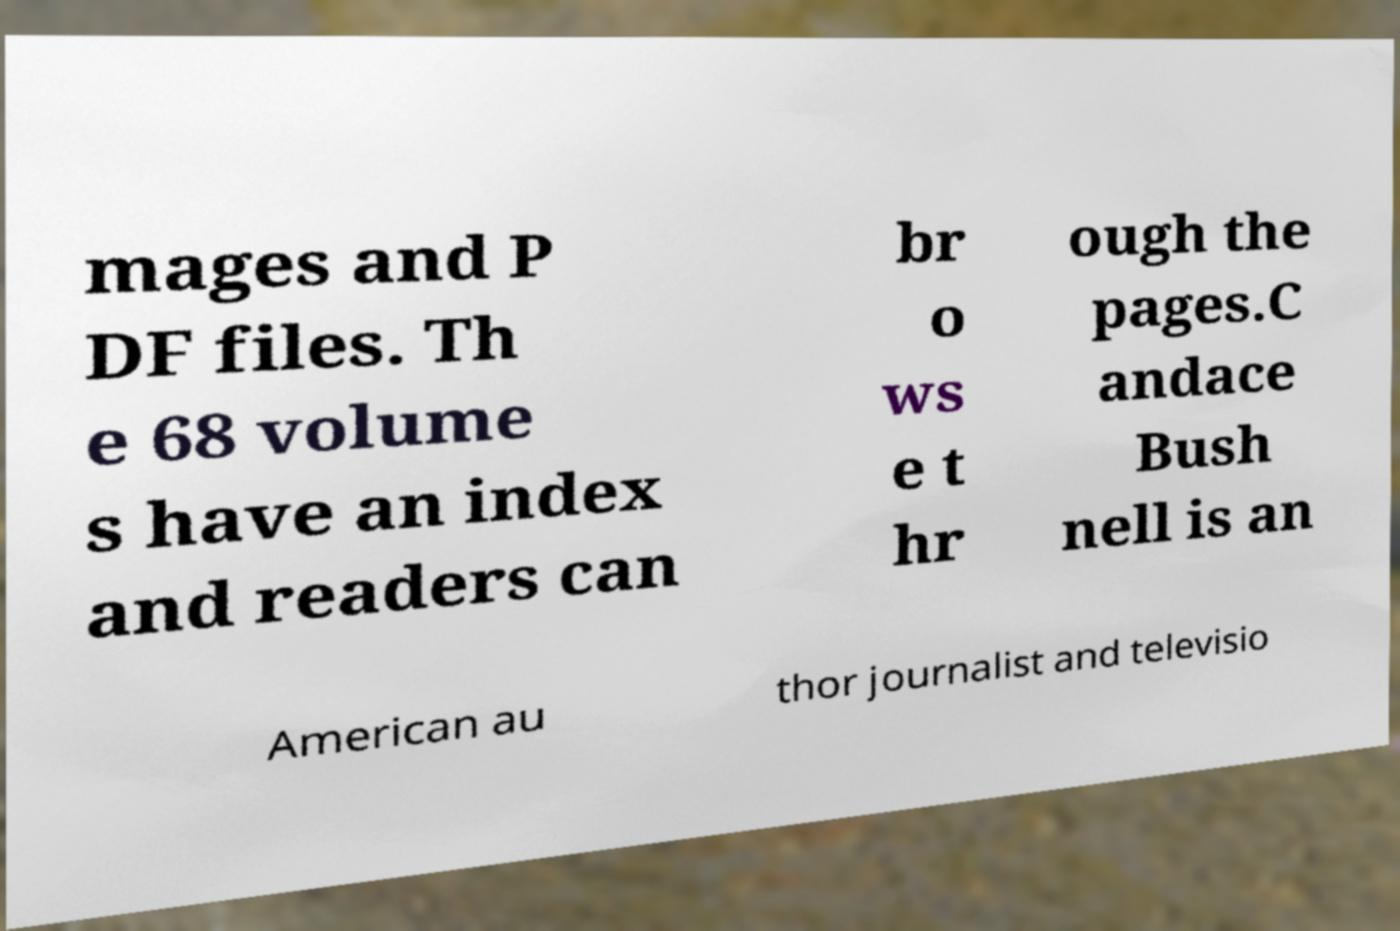Can you accurately transcribe the text from the provided image for me? mages and P DF files. Th e 68 volume s have an index and readers can br o ws e t hr ough the pages.C andace Bush nell is an American au thor journalist and televisio 